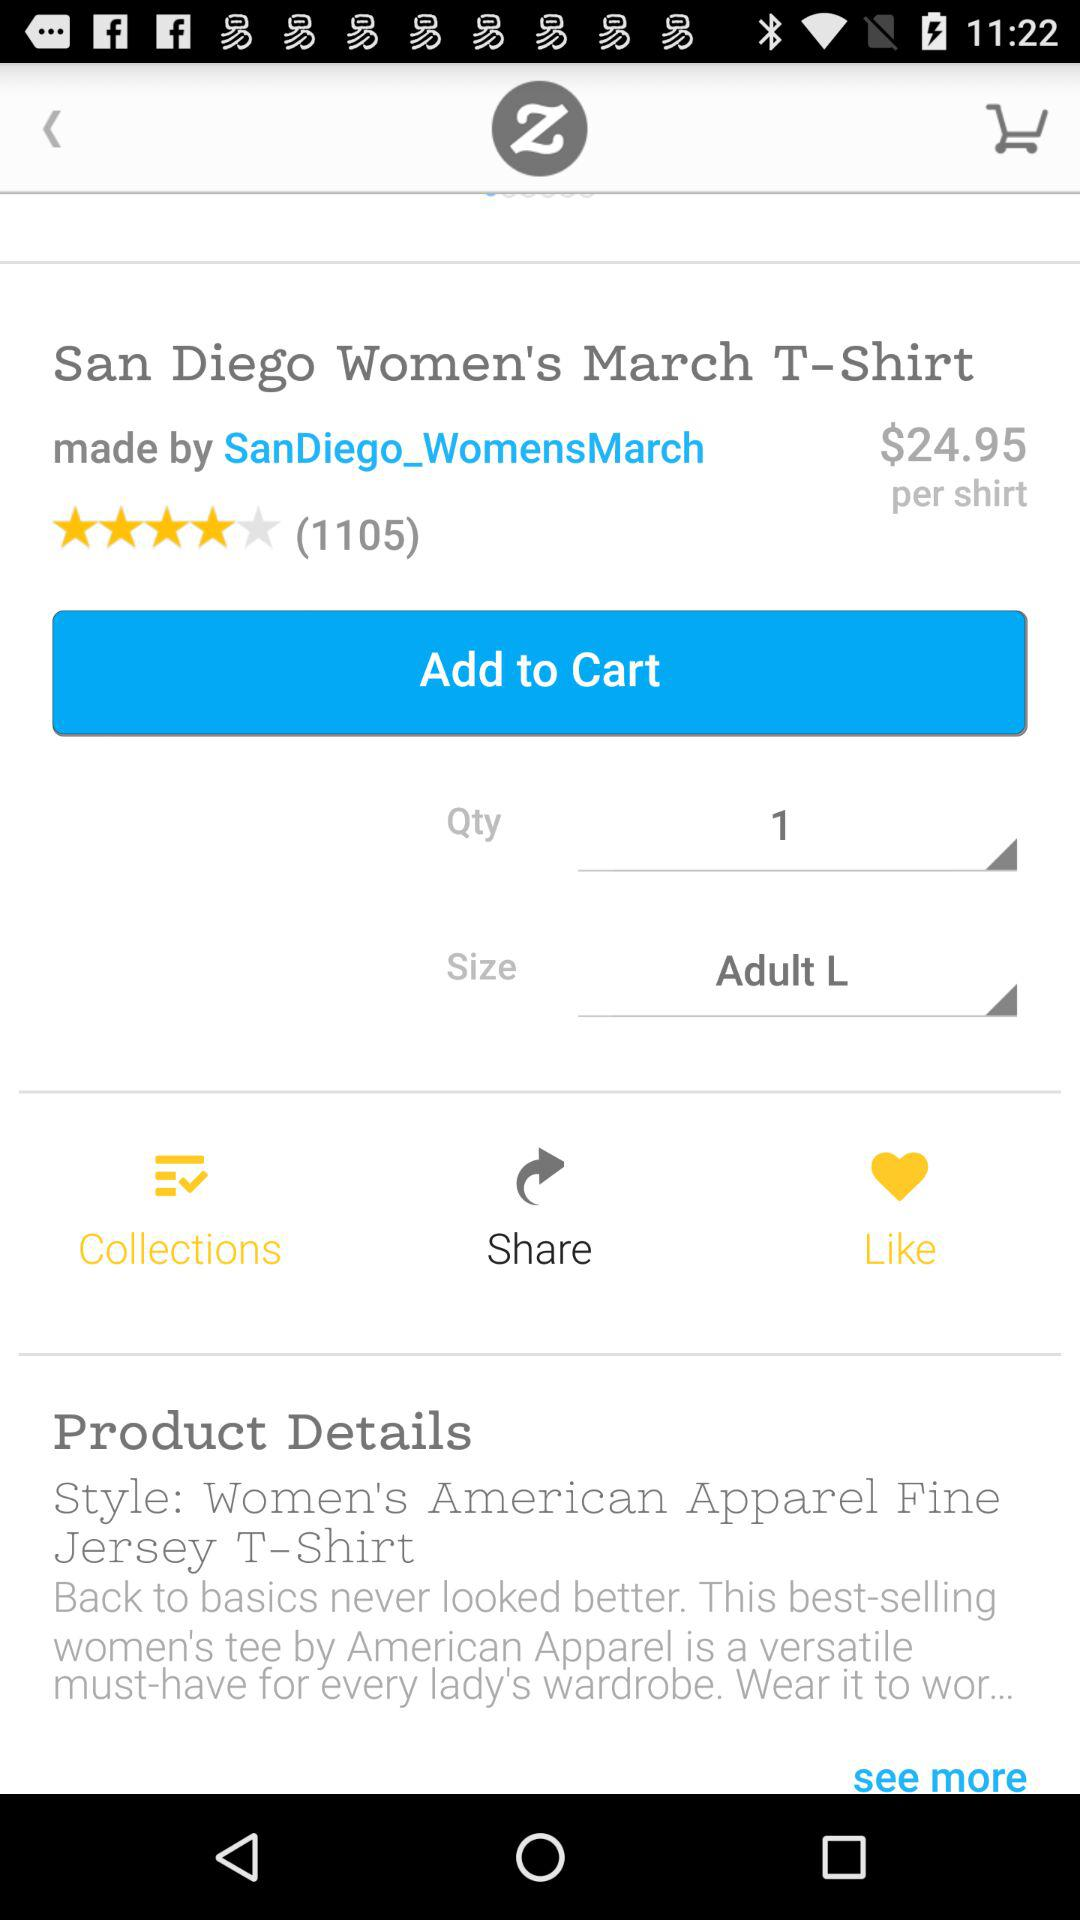What's the price for the t-shirt? The price for the t-shirt is $24.95. 